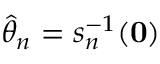<formula> <loc_0><loc_0><loc_500><loc_500>{ \hat { \theta } } _ { n } = s _ { n } ^ { - 1 } ( 0 )</formula> 